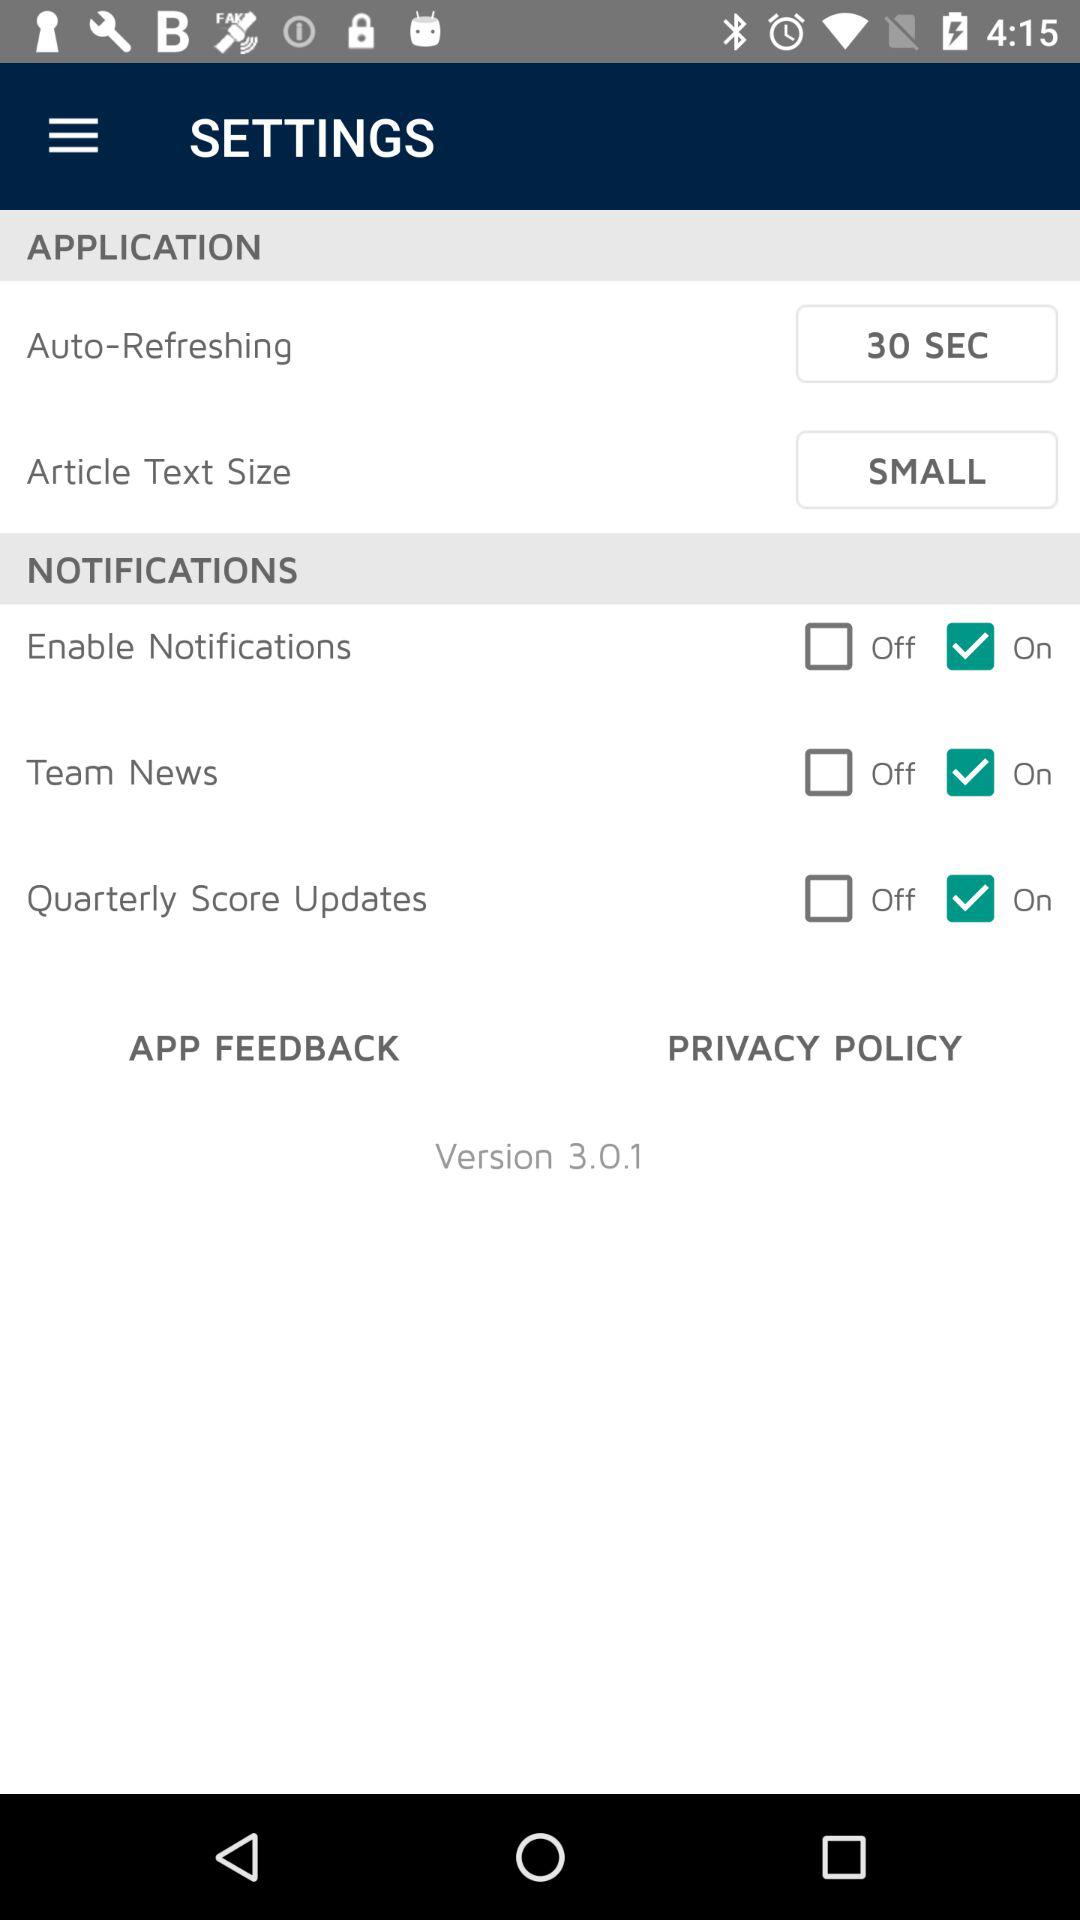Is the "Enable Notifications" option on or off? The "Enable Notifications" option is "on". 